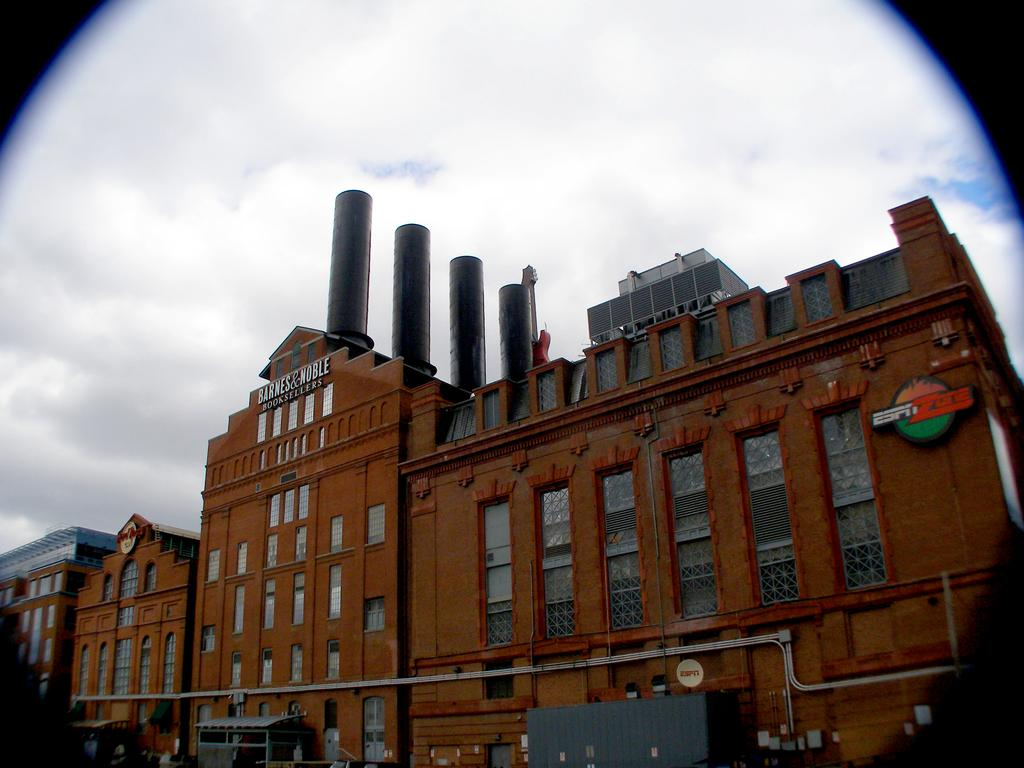What type of structures are visible in the image? There are buildings in the image. What features can be observed on the buildings? The buildings have many windows and chimneys. What is visible in the background of the image? The sky is visible in the image. What can be seen in the sky? Clouds are present in the sky. What type of straw is being used to slip on the buildings in the image? There is no straw or slipping activity present in the image; it features buildings with windows and chimneys, and a sky with clouds. 